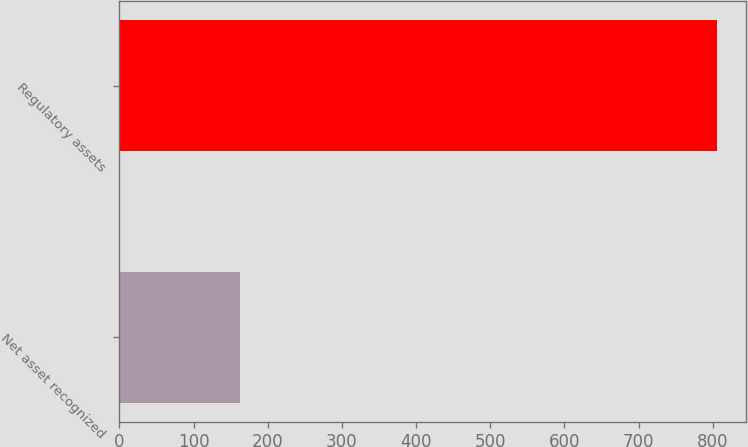Convert chart. <chart><loc_0><loc_0><loc_500><loc_500><bar_chart><fcel>Net asset recognized<fcel>Regulatory assets<nl><fcel>163<fcel>805<nl></chart> 